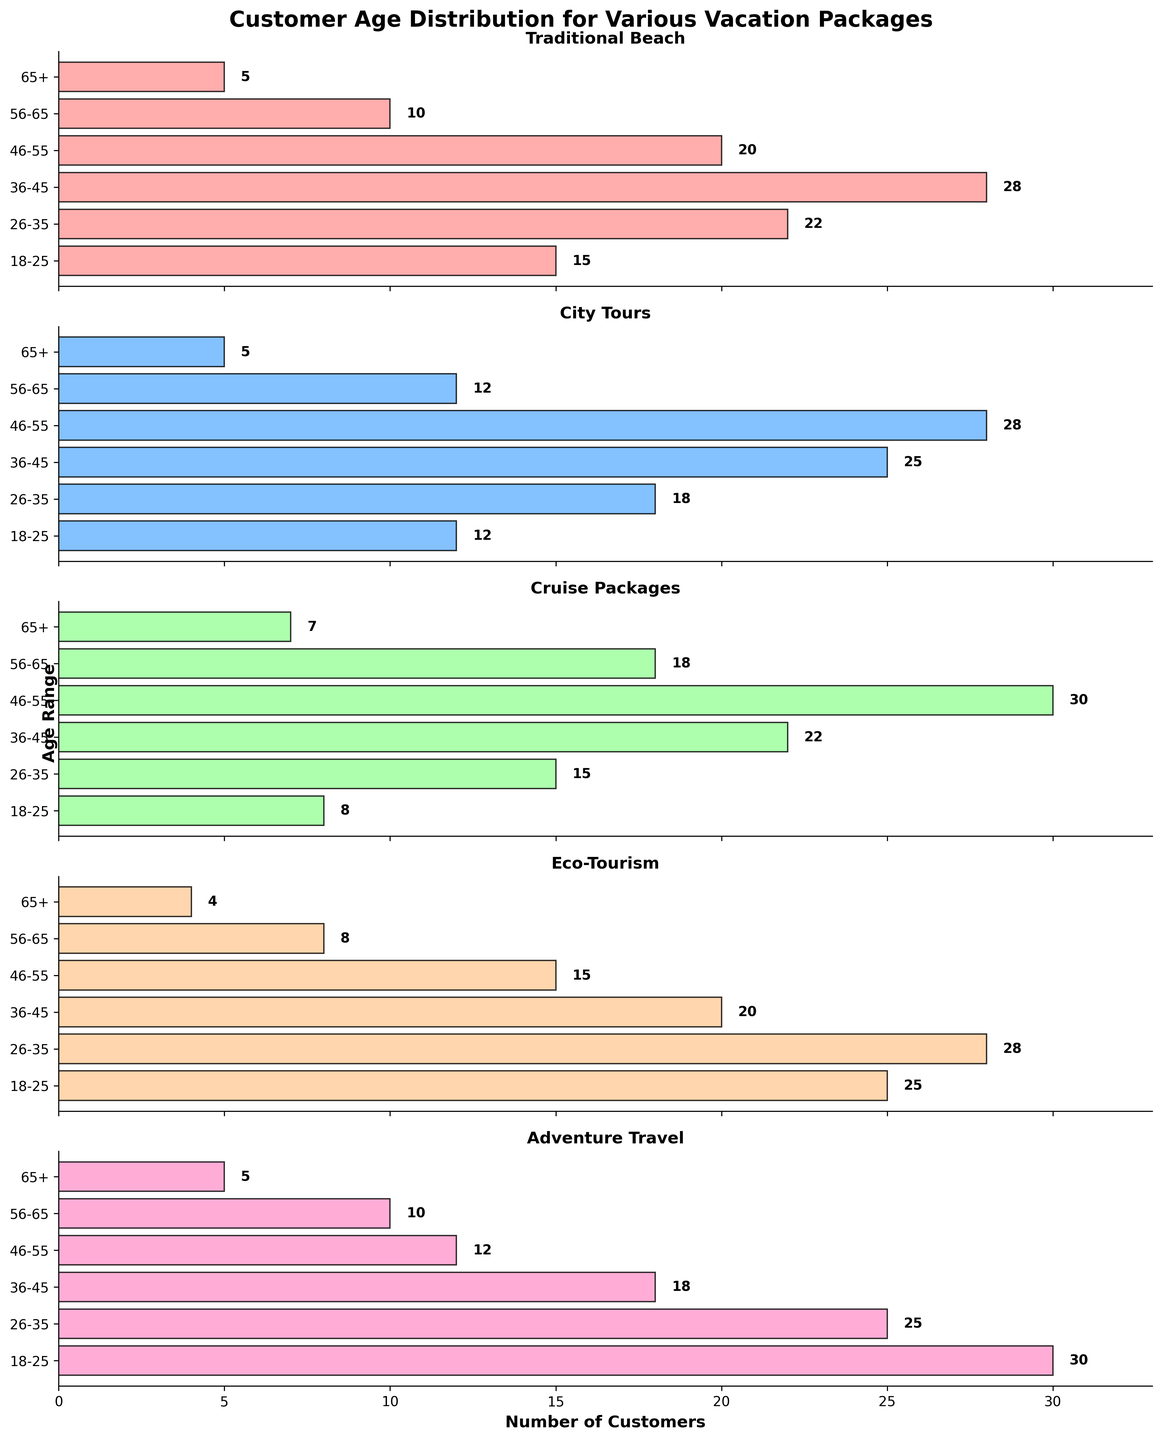What is the title of the figure? The title is usually found at the top of the figure. In this case, it clearly states the content of the subplot.
Answer: Customer Age Distribution for Various Vacation Packages Which vacation package attracts the highest number of 18-25-year-old customers? By looking at the first horizontal bar for each subplot, you can see the highest value. Eco-Tourism has the highest value at 25.
Answer: Eco-Tourism How many customers aged 56-65 prefer Traditional Beach packages? Refer to the bar labeled '56-65' in the 'Traditional Beach' subplot to find the number of customers. The value is 10.
Answer: 10 Which age group shows the most significant interest in Cruise Packages? Identify the longest bar in the 'Cruise Packages' subplot. The bar representing the '46-55' age range is the longest with 30 customers.
Answer: 46-55 Compare the number of customers aged 36-45 between Traditional Beach and Eco-Tourism packages. Look at the '36-45' age group's bars in both subplots and compare the lengths. Traditional Beach has 28 customers, whereas Eco-Tourism has 20.
Answer: Traditional Beach has more What is the total number of customers aged 26-35 for City Tours and Adventure Travel? Add the number of customers for '26-35' in both subplots. City Tours has 18 and Adventure Travel has 25. Summing them gives 18 + 25 = 43.
Answer: 43 In which vacation package is the customer distribution most balanced across age groups? Assess each subplot's bar lengths for uniformity. Adventure Travel's bars are the most evenly distributed without extreme highs or lows.
Answer: Adventure Travel Which age range has the least interest in Eco-Tourism? Look for the shortest bar in the Eco-Tourism subplot. The '65+' age range has the least interest with just 4 customers.
Answer: 65+ Calculate the average number of customers aged 18-25 across all vacation packages. Sum the '18-25' numbers for each package (15+12+8+25+30) and divide by 5. The sum is 90, thus 90/5 = 18.
Answer: 18 